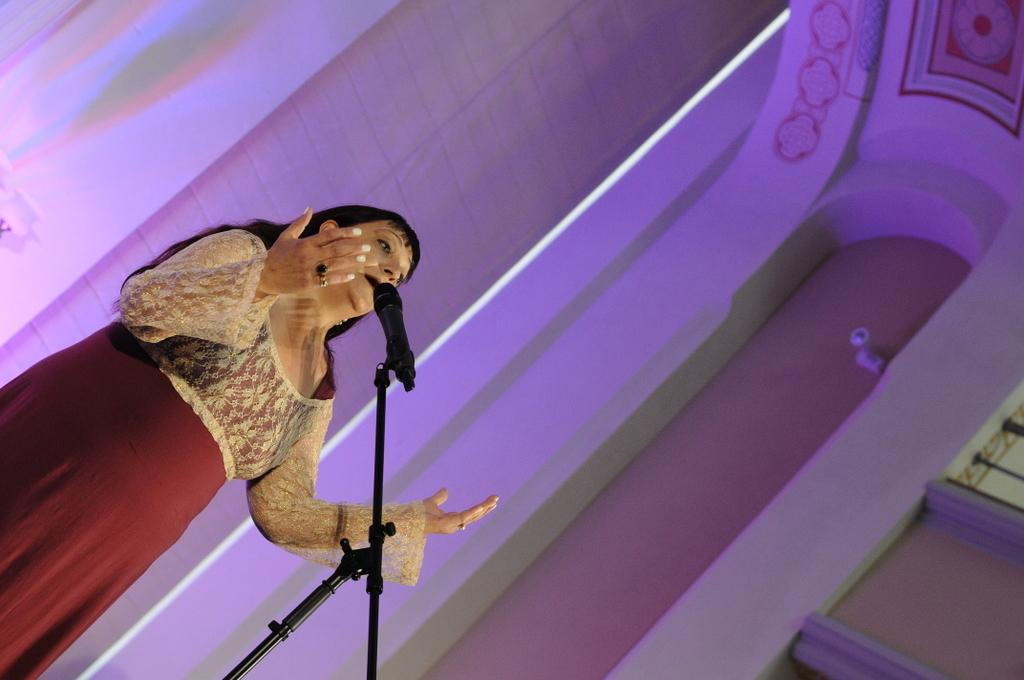What is the main subject of the image? The main subject of the image is a woman. What is the woman doing in the image? The woman is standing and speaking something. What object is in front of the woman? There is a microphone in front of the woman. What can be seen in the background of the image? There is a wall in the background of the image. What type of feather is the woman using to write her speech in the image? There is no feather or writing instrument visible in the image; the woman is speaking into a microphone. Can you tell me how many quills are present in the image? There are no quills present in the image. 